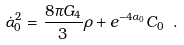<formula> <loc_0><loc_0><loc_500><loc_500>\dot { \alpha } _ { 0 } ^ { 2 } = \frac { 8 \pi G _ { 4 } } { 3 } \rho + e ^ { - 4 \alpha _ { 0 } } C _ { 0 } \ .</formula> 